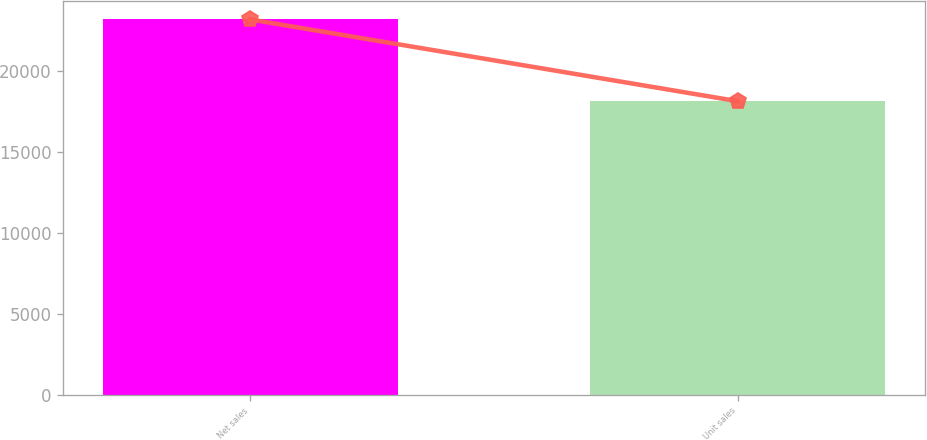Convert chart. <chart><loc_0><loc_0><loc_500><loc_500><bar_chart><fcel>Net sales<fcel>Unit sales<nl><fcel>23221<fcel>18158<nl></chart> 